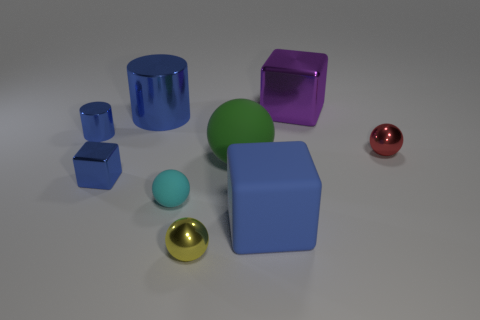Is the number of small red spheres right of the red thing greater than the number of tiny gray shiny cylinders?
Make the answer very short. No. What number of yellow spheres have the same size as the red metal object?
Provide a succinct answer. 1. What size is the rubber cube that is the same color as the small metal block?
Your response must be concise. Large. What number of objects are tiny metal cylinders or blue objects that are on the left side of the yellow ball?
Give a very brief answer. 3. There is a metallic object that is both to the right of the large blue cylinder and left of the green rubber thing; what is its color?
Ensure brevity in your answer.  Yellow. Is the size of the yellow ball the same as the red shiny object?
Your response must be concise. Yes. What is the color of the shiny object in front of the rubber cube?
Offer a terse response. Yellow. Are there any large shiny balls that have the same color as the small shiny cylinder?
Provide a succinct answer. No. There is a matte object that is the same size as the rubber block; what color is it?
Your answer should be compact. Green. Is the tiny red object the same shape as the blue rubber thing?
Provide a short and direct response. No. 